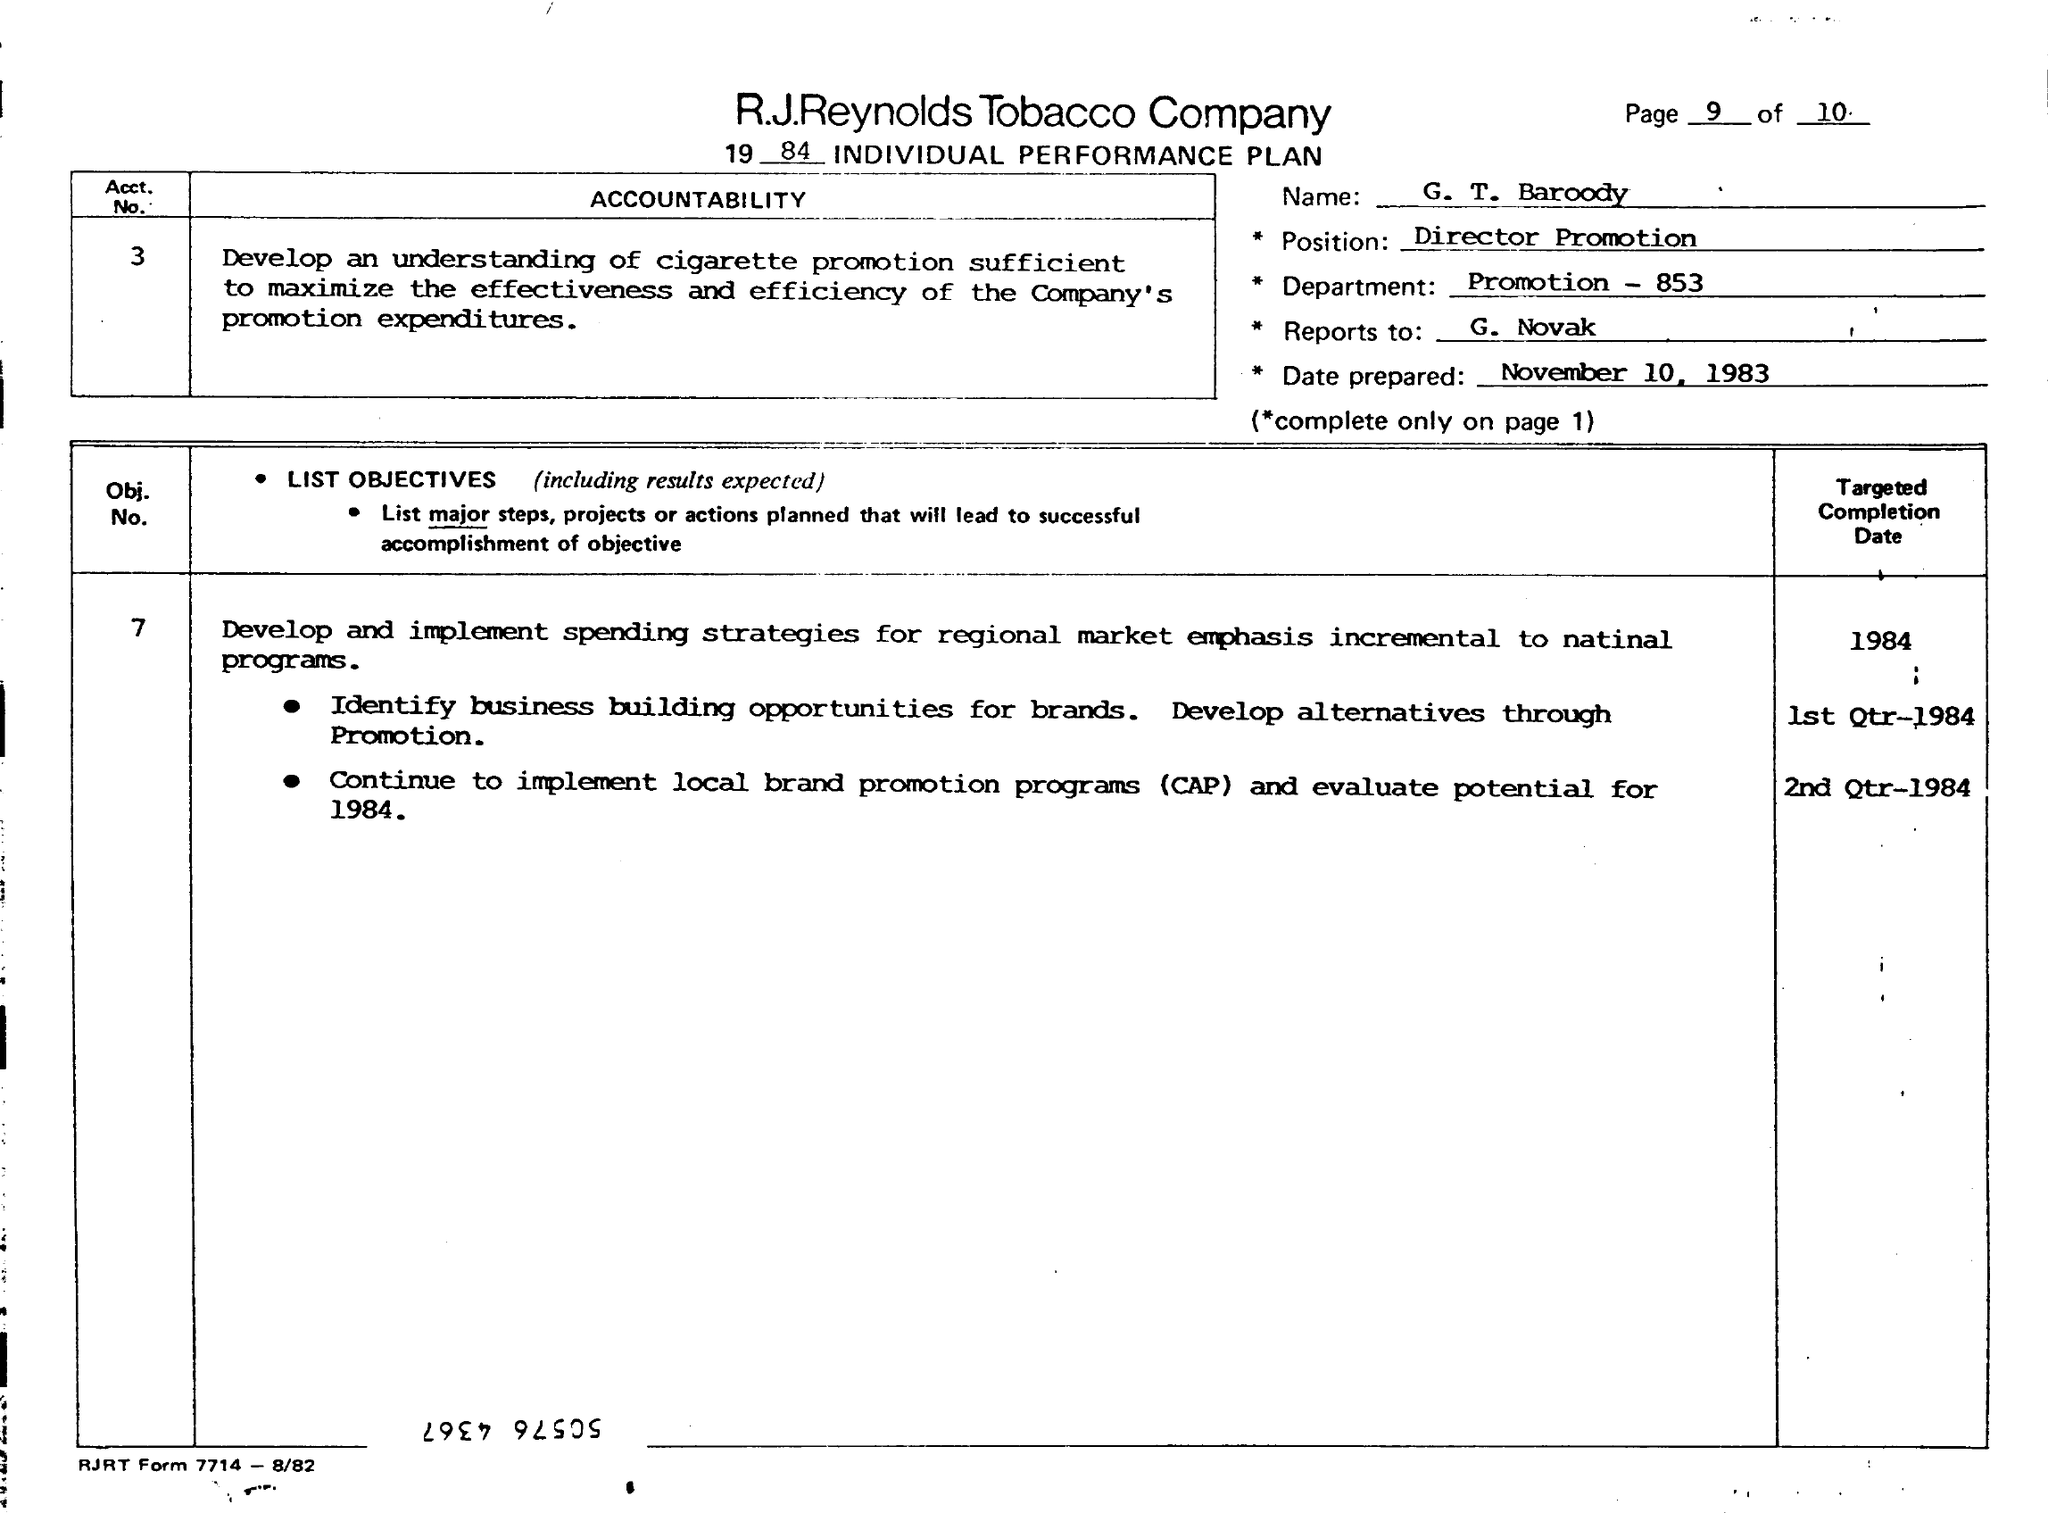What is the name of the company ?
Provide a short and direct response. R.J.Reynolds Tobacco Company. Who's name is mentioned in the individual performance plan ?
Ensure brevity in your answer.  G.T. Baroody. What is the position mentioned in the plan ?
Your response must be concise. Director promotion. On which date this plan is prepared ?
Keep it short and to the point. November 10 , 1983. 